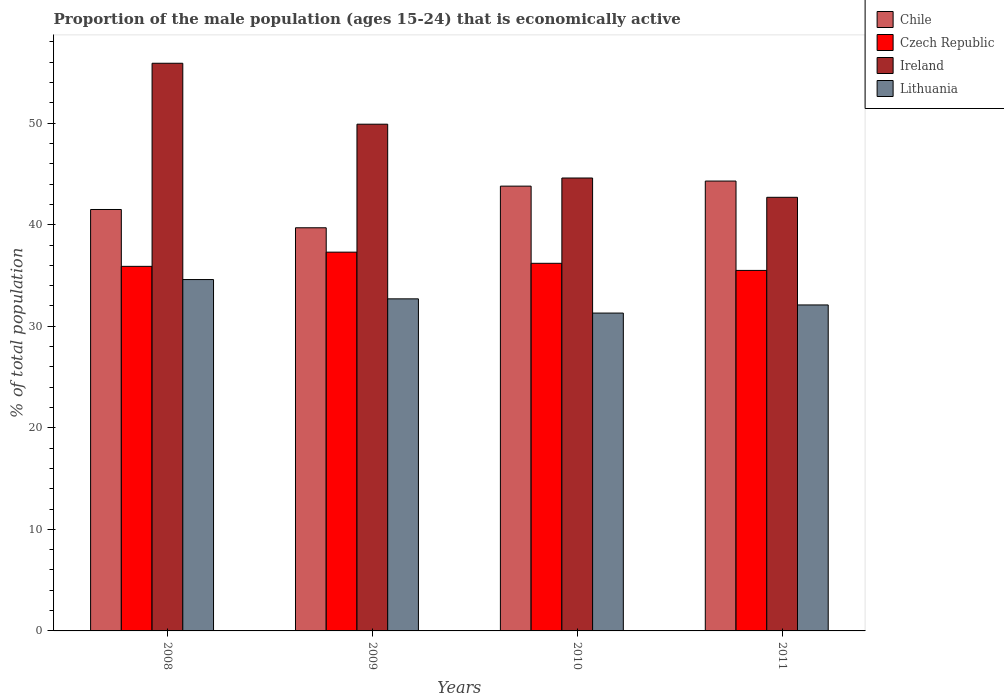How many different coloured bars are there?
Keep it short and to the point. 4. How many groups of bars are there?
Offer a very short reply. 4. Are the number of bars per tick equal to the number of legend labels?
Your answer should be compact. Yes. Are the number of bars on each tick of the X-axis equal?
Keep it short and to the point. Yes. How many bars are there on the 3rd tick from the left?
Offer a very short reply. 4. In how many cases, is the number of bars for a given year not equal to the number of legend labels?
Your answer should be very brief. 0. What is the proportion of the male population that is economically active in Lithuania in 2009?
Provide a short and direct response. 32.7. Across all years, what is the maximum proportion of the male population that is economically active in Chile?
Offer a terse response. 44.3. Across all years, what is the minimum proportion of the male population that is economically active in Lithuania?
Provide a succinct answer. 31.3. In which year was the proportion of the male population that is economically active in Ireland maximum?
Provide a succinct answer. 2008. In which year was the proportion of the male population that is economically active in Chile minimum?
Keep it short and to the point. 2009. What is the total proportion of the male population that is economically active in Ireland in the graph?
Your answer should be compact. 193.1. What is the difference between the proportion of the male population that is economically active in Chile in 2010 and that in 2011?
Provide a short and direct response. -0.5. What is the difference between the proportion of the male population that is economically active in Czech Republic in 2011 and the proportion of the male population that is economically active in Ireland in 2010?
Keep it short and to the point. -9.1. What is the average proportion of the male population that is economically active in Chile per year?
Ensure brevity in your answer.  42.32. In how many years, is the proportion of the male population that is economically active in Ireland greater than 40 %?
Ensure brevity in your answer.  4. What is the ratio of the proportion of the male population that is economically active in Czech Republic in 2009 to that in 2011?
Give a very brief answer. 1.05. Is the proportion of the male population that is economically active in Lithuania in 2009 less than that in 2010?
Keep it short and to the point. No. Is the difference between the proportion of the male population that is economically active in Czech Republic in 2008 and 2011 greater than the difference between the proportion of the male population that is economically active in Ireland in 2008 and 2011?
Provide a succinct answer. No. What is the difference between the highest and the second highest proportion of the male population that is economically active in Lithuania?
Keep it short and to the point. 1.9. What is the difference between the highest and the lowest proportion of the male population that is economically active in Chile?
Offer a very short reply. 4.6. In how many years, is the proportion of the male population that is economically active in Chile greater than the average proportion of the male population that is economically active in Chile taken over all years?
Give a very brief answer. 2. Is the sum of the proportion of the male population that is economically active in Lithuania in 2008 and 2011 greater than the maximum proportion of the male population that is economically active in Czech Republic across all years?
Your answer should be very brief. Yes. What does the 3rd bar from the left in 2011 represents?
Provide a succinct answer. Ireland. Is it the case that in every year, the sum of the proportion of the male population that is economically active in Lithuania and proportion of the male population that is economically active in Chile is greater than the proportion of the male population that is economically active in Ireland?
Offer a very short reply. Yes. How many bars are there?
Your answer should be very brief. 16. Are the values on the major ticks of Y-axis written in scientific E-notation?
Offer a very short reply. No. Does the graph contain grids?
Your response must be concise. No. Where does the legend appear in the graph?
Your answer should be compact. Top right. How are the legend labels stacked?
Offer a very short reply. Vertical. What is the title of the graph?
Make the answer very short. Proportion of the male population (ages 15-24) that is economically active. What is the label or title of the X-axis?
Offer a terse response. Years. What is the label or title of the Y-axis?
Make the answer very short. % of total population. What is the % of total population in Chile in 2008?
Your answer should be very brief. 41.5. What is the % of total population of Czech Republic in 2008?
Make the answer very short. 35.9. What is the % of total population of Ireland in 2008?
Provide a succinct answer. 55.9. What is the % of total population of Lithuania in 2008?
Make the answer very short. 34.6. What is the % of total population in Chile in 2009?
Provide a succinct answer. 39.7. What is the % of total population of Czech Republic in 2009?
Keep it short and to the point. 37.3. What is the % of total population of Ireland in 2009?
Provide a succinct answer. 49.9. What is the % of total population of Lithuania in 2009?
Your answer should be compact. 32.7. What is the % of total population in Chile in 2010?
Offer a very short reply. 43.8. What is the % of total population in Czech Republic in 2010?
Give a very brief answer. 36.2. What is the % of total population in Ireland in 2010?
Offer a very short reply. 44.6. What is the % of total population of Lithuania in 2010?
Ensure brevity in your answer.  31.3. What is the % of total population of Chile in 2011?
Your response must be concise. 44.3. What is the % of total population of Czech Republic in 2011?
Your answer should be compact. 35.5. What is the % of total population in Ireland in 2011?
Your answer should be compact. 42.7. What is the % of total population of Lithuania in 2011?
Offer a very short reply. 32.1. Across all years, what is the maximum % of total population of Chile?
Give a very brief answer. 44.3. Across all years, what is the maximum % of total population of Czech Republic?
Ensure brevity in your answer.  37.3. Across all years, what is the maximum % of total population of Ireland?
Your response must be concise. 55.9. Across all years, what is the maximum % of total population of Lithuania?
Make the answer very short. 34.6. Across all years, what is the minimum % of total population of Chile?
Provide a succinct answer. 39.7. Across all years, what is the minimum % of total population of Czech Republic?
Provide a short and direct response. 35.5. Across all years, what is the minimum % of total population of Ireland?
Keep it short and to the point. 42.7. Across all years, what is the minimum % of total population in Lithuania?
Your response must be concise. 31.3. What is the total % of total population in Chile in the graph?
Provide a succinct answer. 169.3. What is the total % of total population of Czech Republic in the graph?
Offer a terse response. 144.9. What is the total % of total population of Ireland in the graph?
Your response must be concise. 193.1. What is the total % of total population of Lithuania in the graph?
Provide a short and direct response. 130.7. What is the difference between the % of total population of Czech Republic in 2008 and that in 2009?
Give a very brief answer. -1.4. What is the difference between the % of total population of Ireland in 2008 and that in 2009?
Your response must be concise. 6. What is the difference between the % of total population of Lithuania in 2008 and that in 2009?
Ensure brevity in your answer.  1.9. What is the difference between the % of total population of Chile in 2008 and that in 2010?
Offer a terse response. -2.3. What is the difference between the % of total population of Chile in 2008 and that in 2011?
Your answer should be compact. -2.8. What is the difference between the % of total population of Czech Republic in 2008 and that in 2011?
Ensure brevity in your answer.  0.4. What is the difference between the % of total population in Ireland in 2008 and that in 2011?
Offer a very short reply. 13.2. What is the difference between the % of total population in Lithuania in 2008 and that in 2011?
Make the answer very short. 2.5. What is the difference between the % of total population of Chile in 2009 and that in 2010?
Your response must be concise. -4.1. What is the difference between the % of total population in Ireland in 2009 and that in 2010?
Offer a terse response. 5.3. What is the difference between the % of total population in Chile in 2009 and that in 2011?
Provide a succinct answer. -4.6. What is the difference between the % of total population of Czech Republic in 2009 and that in 2011?
Offer a very short reply. 1.8. What is the difference between the % of total population of Ireland in 2009 and that in 2011?
Offer a very short reply. 7.2. What is the difference between the % of total population in Czech Republic in 2010 and that in 2011?
Your answer should be compact. 0.7. What is the difference between the % of total population of Chile in 2008 and the % of total population of Czech Republic in 2009?
Provide a short and direct response. 4.2. What is the difference between the % of total population of Chile in 2008 and the % of total population of Ireland in 2009?
Your answer should be compact. -8.4. What is the difference between the % of total population in Chile in 2008 and the % of total population in Lithuania in 2009?
Your response must be concise. 8.8. What is the difference between the % of total population of Czech Republic in 2008 and the % of total population of Ireland in 2009?
Your answer should be very brief. -14. What is the difference between the % of total population of Ireland in 2008 and the % of total population of Lithuania in 2009?
Your answer should be compact. 23.2. What is the difference between the % of total population in Chile in 2008 and the % of total population in Lithuania in 2010?
Offer a very short reply. 10.2. What is the difference between the % of total population of Czech Republic in 2008 and the % of total population of Lithuania in 2010?
Offer a very short reply. 4.6. What is the difference between the % of total population of Ireland in 2008 and the % of total population of Lithuania in 2010?
Keep it short and to the point. 24.6. What is the difference between the % of total population of Ireland in 2008 and the % of total population of Lithuania in 2011?
Provide a short and direct response. 23.8. What is the difference between the % of total population of Czech Republic in 2009 and the % of total population of Lithuania in 2011?
Give a very brief answer. 5.2. What is the difference between the % of total population in Chile in 2010 and the % of total population in Ireland in 2011?
Provide a succinct answer. 1.1. What is the difference between the % of total population of Chile in 2010 and the % of total population of Lithuania in 2011?
Your response must be concise. 11.7. What is the difference between the % of total population of Czech Republic in 2010 and the % of total population of Ireland in 2011?
Offer a terse response. -6.5. What is the difference between the % of total population in Czech Republic in 2010 and the % of total population in Lithuania in 2011?
Your response must be concise. 4.1. What is the difference between the % of total population of Ireland in 2010 and the % of total population of Lithuania in 2011?
Keep it short and to the point. 12.5. What is the average % of total population in Chile per year?
Your answer should be compact. 42.33. What is the average % of total population in Czech Republic per year?
Provide a short and direct response. 36.23. What is the average % of total population in Ireland per year?
Provide a short and direct response. 48.27. What is the average % of total population in Lithuania per year?
Provide a succinct answer. 32.67. In the year 2008, what is the difference between the % of total population of Chile and % of total population of Czech Republic?
Offer a terse response. 5.6. In the year 2008, what is the difference between the % of total population in Chile and % of total population in Ireland?
Your answer should be compact. -14.4. In the year 2008, what is the difference between the % of total population of Chile and % of total population of Lithuania?
Give a very brief answer. 6.9. In the year 2008, what is the difference between the % of total population of Czech Republic and % of total population of Ireland?
Make the answer very short. -20. In the year 2008, what is the difference between the % of total population in Ireland and % of total population in Lithuania?
Keep it short and to the point. 21.3. In the year 2009, what is the difference between the % of total population of Chile and % of total population of Ireland?
Keep it short and to the point. -10.2. In the year 2009, what is the difference between the % of total population in Chile and % of total population in Lithuania?
Provide a succinct answer. 7. In the year 2010, what is the difference between the % of total population in Chile and % of total population in Ireland?
Give a very brief answer. -0.8. In the year 2010, what is the difference between the % of total population in Chile and % of total population in Lithuania?
Your answer should be very brief. 12.5. In the year 2011, what is the difference between the % of total population of Chile and % of total population of Ireland?
Your answer should be very brief. 1.6. In the year 2011, what is the difference between the % of total population of Czech Republic and % of total population of Ireland?
Your response must be concise. -7.2. In the year 2011, what is the difference between the % of total population in Czech Republic and % of total population in Lithuania?
Provide a short and direct response. 3.4. What is the ratio of the % of total population of Chile in 2008 to that in 2009?
Keep it short and to the point. 1.05. What is the ratio of the % of total population of Czech Republic in 2008 to that in 2009?
Give a very brief answer. 0.96. What is the ratio of the % of total population in Ireland in 2008 to that in 2009?
Make the answer very short. 1.12. What is the ratio of the % of total population in Lithuania in 2008 to that in 2009?
Keep it short and to the point. 1.06. What is the ratio of the % of total population of Chile in 2008 to that in 2010?
Offer a terse response. 0.95. What is the ratio of the % of total population of Czech Republic in 2008 to that in 2010?
Your answer should be compact. 0.99. What is the ratio of the % of total population of Ireland in 2008 to that in 2010?
Offer a very short reply. 1.25. What is the ratio of the % of total population in Lithuania in 2008 to that in 2010?
Your response must be concise. 1.11. What is the ratio of the % of total population of Chile in 2008 to that in 2011?
Offer a very short reply. 0.94. What is the ratio of the % of total population of Czech Republic in 2008 to that in 2011?
Offer a terse response. 1.01. What is the ratio of the % of total population of Ireland in 2008 to that in 2011?
Make the answer very short. 1.31. What is the ratio of the % of total population in Lithuania in 2008 to that in 2011?
Provide a short and direct response. 1.08. What is the ratio of the % of total population of Chile in 2009 to that in 2010?
Your answer should be compact. 0.91. What is the ratio of the % of total population of Czech Republic in 2009 to that in 2010?
Provide a succinct answer. 1.03. What is the ratio of the % of total population of Ireland in 2009 to that in 2010?
Provide a short and direct response. 1.12. What is the ratio of the % of total population of Lithuania in 2009 to that in 2010?
Offer a very short reply. 1.04. What is the ratio of the % of total population in Chile in 2009 to that in 2011?
Offer a very short reply. 0.9. What is the ratio of the % of total population of Czech Republic in 2009 to that in 2011?
Offer a very short reply. 1.05. What is the ratio of the % of total population of Ireland in 2009 to that in 2011?
Provide a succinct answer. 1.17. What is the ratio of the % of total population in Lithuania in 2009 to that in 2011?
Your answer should be very brief. 1.02. What is the ratio of the % of total population of Chile in 2010 to that in 2011?
Your answer should be very brief. 0.99. What is the ratio of the % of total population of Czech Republic in 2010 to that in 2011?
Your response must be concise. 1.02. What is the ratio of the % of total population of Ireland in 2010 to that in 2011?
Ensure brevity in your answer.  1.04. What is the ratio of the % of total population of Lithuania in 2010 to that in 2011?
Your response must be concise. 0.98. What is the difference between the highest and the second highest % of total population of Chile?
Make the answer very short. 0.5. What is the difference between the highest and the second highest % of total population in Czech Republic?
Your answer should be compact. 1.1. What is the difference between the highest and the lowest % of total population of Chile?
Your answer should be compact. 4.6. What is the difference between the highest and the lowest % of total population of Ireland?
Offer a very short reply. 13.2. 